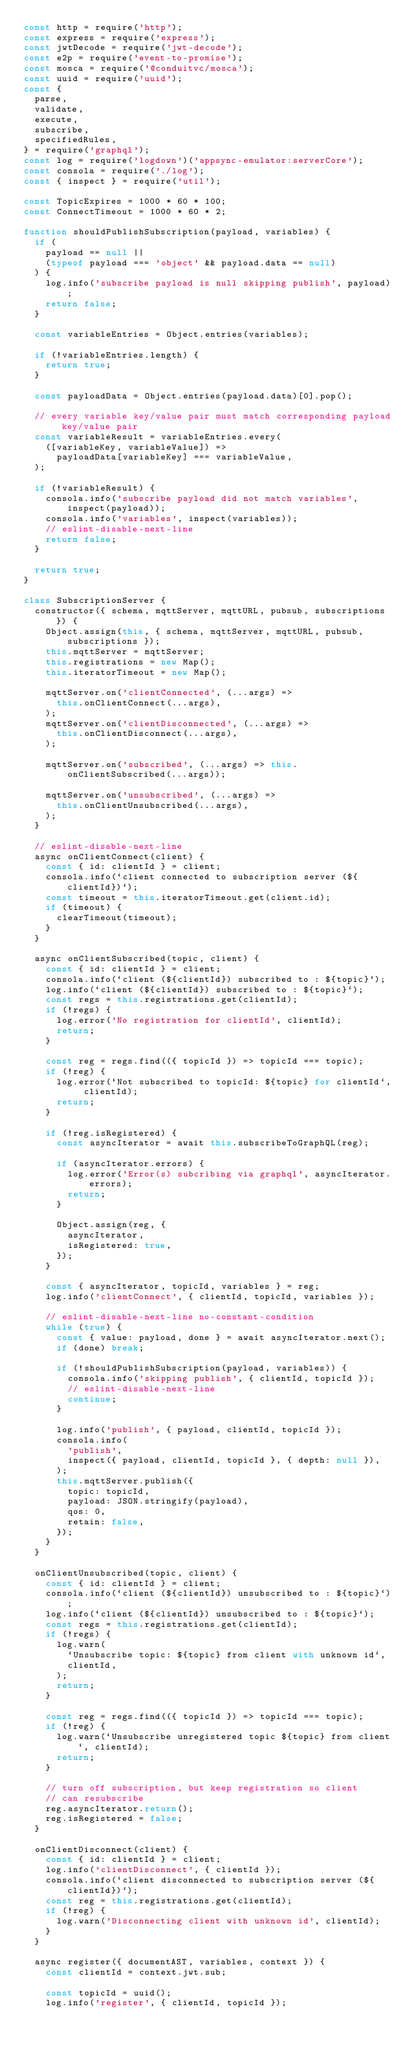<code> <loc_0><loc_0><loc_500><loc_500><_JavaScript_>const http = require('http');
const express = require('express');
const jwtDecode = require('jwt-decode');
const e2p = require('event-to-promise');
const mosca = require('@conduitvc/mosca');
const uuid = require('uuid');
const {
  parse,
  validate,
  execute,
  subscribe,
  specifiedRules,
} = require('graphql');
const log = require('logdown')('appsync-emulator:serverCore');
const consola = require('./log');
const { inspect } = require('util');

const TopicExpires = 1000 * 60 * 100;
const ConnectTimeout = 1000 * 60 * 2;

function shouldPublishSubscription(payload, variables) {
  if (
    payload == null ||
    (typeof payload === 'object' && payload.data == null)
  ) {
    log.info('subscribe payload is null skipping publish', payload);
    return false;
  }

  const variableEntries = Object.entries(variables);

  if (!variableEntries.length) {
    return true;
  }

  const payloadData = Object.entries(payload.data)[0].pop();

  // every variable key/value pair must match corresponding payload key/value pair
  const variableResult = variableEntries.every(
    ([variableKey, variableValue]) =>
      payloadData[variableKey] === variableValue,
  );

  if (!variableResult) {
    consola.info('subscribe payload did not match variables', inspect(payload));
    consola.info('variables', inspect(variables));
    // eslint-disable-next-line
    return false;
  }

  return true;
}

class SubscriptionServer {
  constructor({ schema, mqttServer, mqttURL, pubsub, subscriptions }) {
    Object.assign(this, { schema, mqttServer, mqttURL, pubsub, subscriptions });
    this.mqttServer = mqttServer;
    this.registrations = new Map();
    this.iteratorTimeout = new Map();

    mqttServer.on('clientConnected', (...args) =>
      this.onClientConnect(...args),
    );
    mqttServer.on('clientDisconnected', (...args) =>
      this.onClientDisconnect(...args),
    );

    mqttServer.on('subscribed', (...args) => this.onClientSubscribed(...args));

    mqttServer.on('unsubscribed', (...args) =>
      this.onClientUnsubscribed(...args),
    );
  }

  // eslint-disable-next-line
  async onClientConnect(client) {
    const { id: clientId } = client;
    consola.info(`client connected to subscription server (${clientId})`);
    const timeout = this.iteratorTimeout.get(client.id);
    if (timeout) {
      clearTimeout(timeout);
    }
  }

  async onClientSubscribed(topic, client) {
    const { id: clientId } = client;
    consola.info(`client (${clientId}) subscribed to : ${topic}`);
    log.info(`client (${clientId}) subscribed to : ${topic}`);
    const regs = this.registrations.get(clientId);
    if (!regs) {
      log.error('No registration for clientId', clientId);
      return;
    }

    const reg = regs.find(({ topicId }) => topicId === topic);
    if (!reg) {
      log.error(`Not subscribed to topicId: ${topic} for clientId`, clientId);
      return;
    }

    if (!reg.isRegistered) {
      const asyncIterator = await this.subscribeToGraphQL(reg);

      if (asyncIterator.errors) {
        log.error('Error(s) subcribing via graphql', asyncIterator.errors);
        return;
      }

      Object.assign(reg, {
        asyncIterator,
        isRegistered: true,
      });
    }

    const { asyncIterator, topicId, variables } = reg;
    log.info('clientConnect', { clientId, topicId, variables });

    // eslint-disable-next-line no-constant-condition
    while (true) {
      const { value: payload, done } = await asyncIterator.next();
      if (done) break;

      if (!shouldPublishSubscription(payload, variables)) {
        consola.info('skipping publish', { clientId, topicId });
        // eslint-disable-next-line
        continue;
      }

      log.info('publish', { payload, clientId, topicId });
      consola.info(
        'publish',
        inspect({ payload, clientId, topicId }, { depth: null }),
      );
      this.mqttServer.publish({
        topic: topicId,
        payload: JSON.stringify(payload),
        qos: 0,
        retain: false,
      });
    }
  }

  onClientUnsubscribed(topic, client) {
    const { id: clientId } = client;
    consola.info(`client (${clientId}) unsubscribed to : ${topic}`);
    log.info(`client (${clientId}) unsubscribed to : ${topic}`);
    const regs = this.registrations.get(clientId);
    if (!regs) {
      log.warn(
        `Unsubscribe topic: ${topic} from client with unknown id`,
        clientId,
      );
      return;
    }

    const reg = regs.find(({ topicId }) => topicId === topic);
    if (!reg) {
      log.warn(`Unsubscribe unregistered topic ${topic} from client`, clientId);
      return;
    }

    // turn off subscription, but keep registration so client
    // can resubscribe
    reg.asyncIterator.return();
    reg.isRegistered = false;
  }

  onClientDisconnect(client) {
    const { id: clientId } = client;
    log.info('clientDisconnect', { clientId });
    consola.info(`client disconnected to subscription server (${clientId})`);
    const reg = this.registrations.get(clientId);
    if (!reg) {
      log.warn('Disconnecting client with unknown id', clientId);
    }
  }

  async register({ documentAST, variables, context }) {
    const clientId = context.jwt.sub;

    const topicId = uuid();
    log.info('register', { clientId, topicId });
</code> 